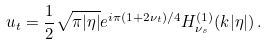<formula> <loc_0><loc_0><loc_500><loc_500>u _ { t } = \frac { 1 } { 2 } \sqrt { \pi | \eta | } e ^ { i \pi ( 1 + 2 \nu _ { t } ) / 4 } H ^ { ( 1 ) } _ { \nu _ { s } } ( k | \eta | ) \, .</formula> 